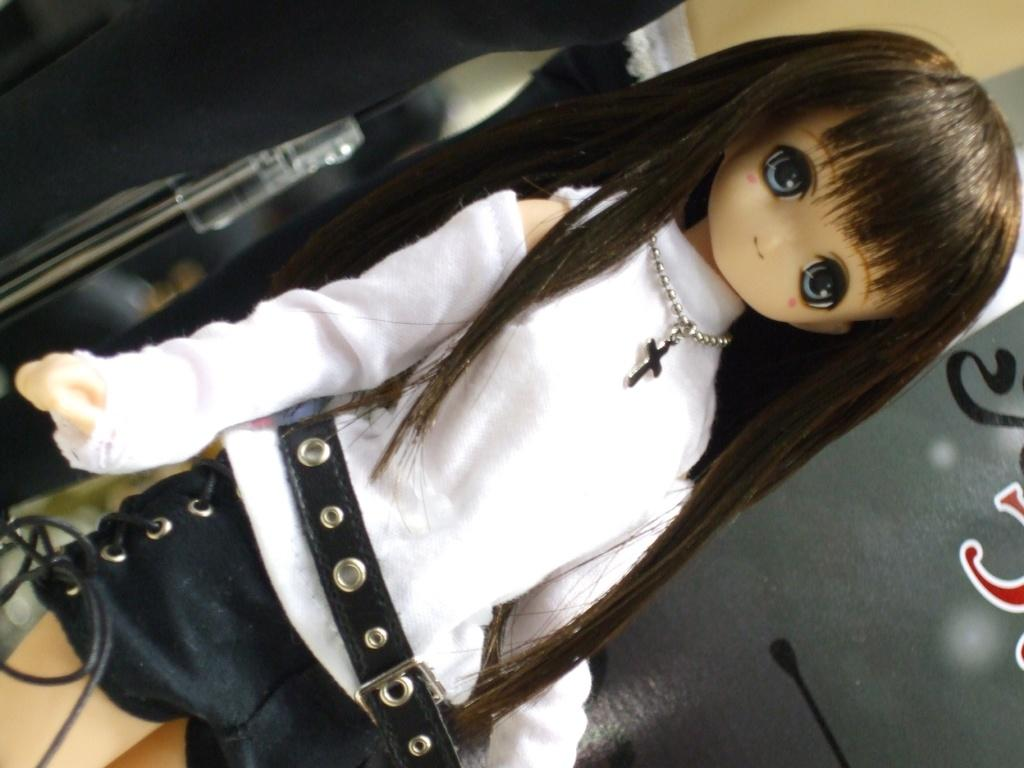What is the main subject in the center of the image? There is a doll in the center of the image. What type of milk is the doll holding in the image? There is no milk present in the image; it features a doll in the center. 